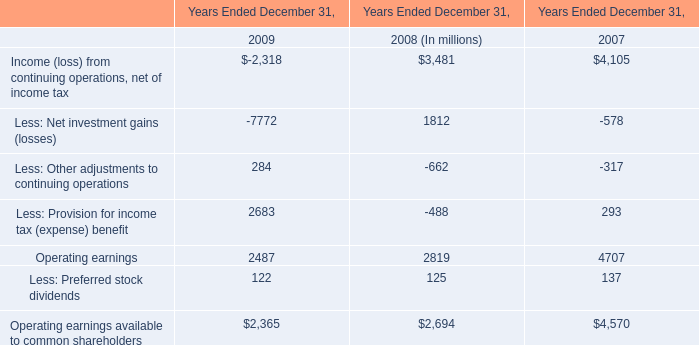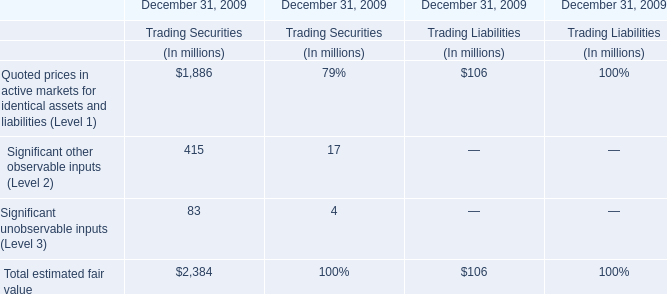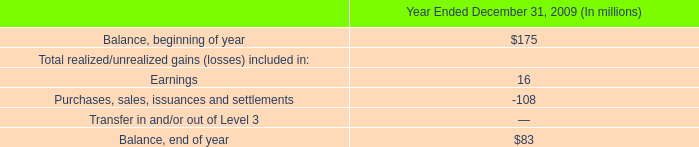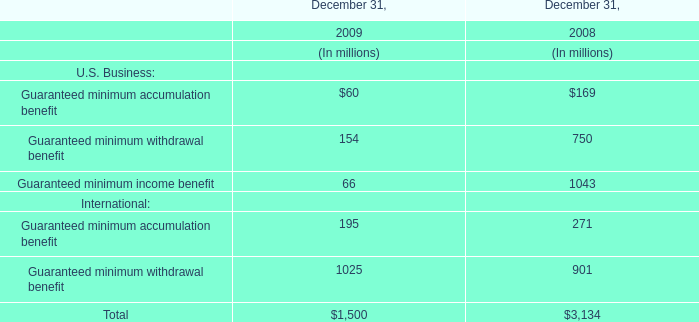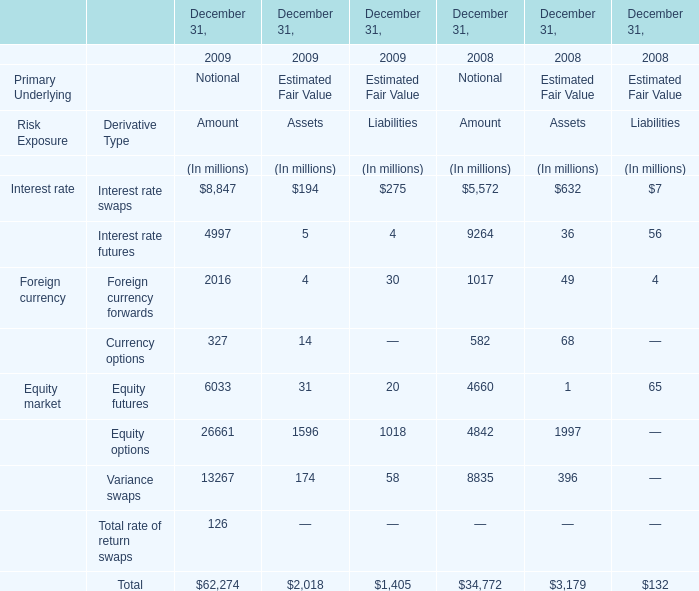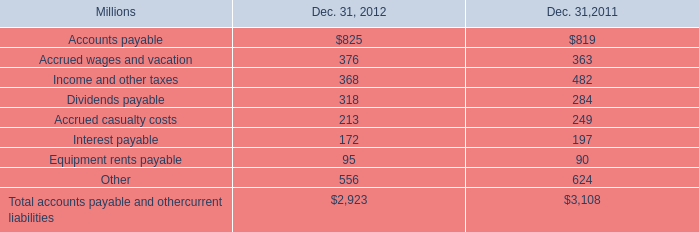what was the percentage change in equipment rents payable from 2011 to 2012? 
Computations: ((95 - 90) / 90)
Answer: 0.05556. 